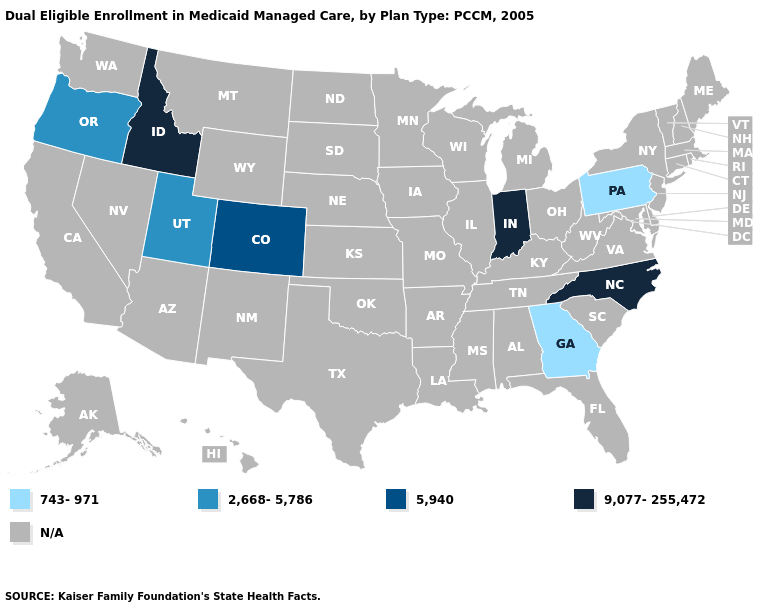What is the lowest value in the USA?
Answer briefly. 743-971. Name the states that have a value in the range 9,077-255,472?
Keep it brief. Idaho, Indiana, North Carolina. What is the lowest value in the West?
Give a very brief answer. 2,668-5,786. Which states have the highest value in the USA?
Be succinct. Idaho, Indiana, North Carolina. Which states have the lowest value in the USA?
Concise answer only. Georgia, Pennsylvania. What is the highest value in states that border Washington?
Short answer required. 9,077-255,472. What is the value of Nebraska?
Concise answer only. N/A. Which states hav the highest value in the West?
Short answer required. Idaho. Name the states that have a value in the range 2,668-5,786?
Be succinct. Oregon, Utah. Name the states that have a value in the range N/A?
Give a very brief answer. Alabama, Alaska, Arizona, Arkansas, California, Connecticut, Delaware, Florida, Hawaii, Illinois, Iowa, Kansas, Kentucky, Louisiana, Maine, Maryland, Massachusetts, Michigan, Minnesota, Mississippi, Missouri, Montana, Nebraska, Nevada, New Hampshire, New Jersey, New Mexico, New York, North Dakota, Ohio, Oklahoma, Rhode Island, South Carolina, South Dakota, Tennessee, Texas, Vermont, Virginia, Washington, West Virginia, Wisconsin, Wyoming. 